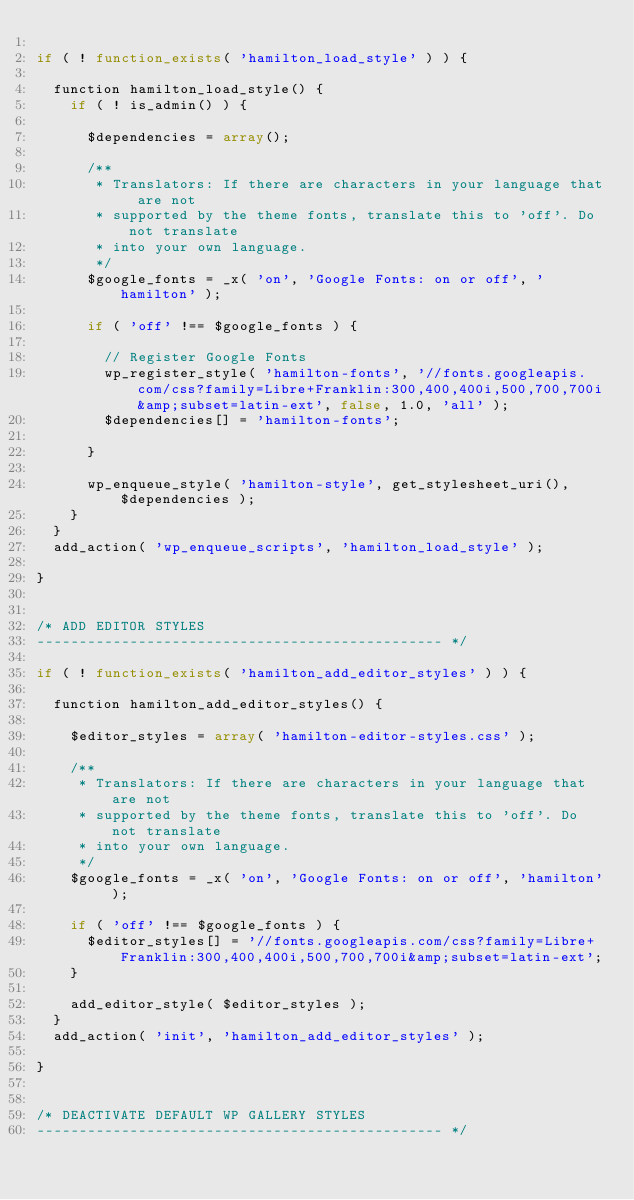Convert code to text. <code><loc_0><loc_0><loc_500><loc_500><_PHP_>
if ( ! function_exists( 'hamilton_load_style' ) ) {

	function hamilton_load_style() {
		if ( ! is_admin() ) {

			$dependencies = array();

			/**
			 * Translators: If there are characters in your language that are not
			 * supported by the theme fonts, translate this to 'off'. Do not translate
			 * into your own language.
			 */
			$google_fonts = _x( 'on', 'Google Fonts: on or off', 'hamilton' );

			if ( 'off' !== $google_fonts ) {

				// Register Google Fonts
				wp_register_style( 'hamilton-fonts', '//fonts.googleapis.com/css?family=Libre+Franklin:300,400,400i,500,700,700i&amp;subset=latin-ext', false, 1.0, 'all' );
				$dependencies[] = 'hamilton-fonts';

			}

			wp_enqueue_style( 'hamilton-style', get_stylesheet_uri(), $dependencies );
		} 
	}
	add_action( 'wp_enqueue_scripts', 'hamilton_load_style' );

}


/* ADD EDITOR STYLES
------------------------------------------------ */

if ( ! function_exists( 'hamilton_add_editor_styles' ) ) {

	function hamilton_add_editor_styles() {

		$editor_styles = array( 'hamilton-editor-styles.css' );

		/**
		 * Translators: If there are characters in your language that are not
		 * supported by the theme fonts, translate this to 'off'. Do not translate
		 * into your own language.
		 */
		$google_fonts = _x( 'on', 'Google Fonts: on or off', 'hamilton' );

		if ( 'off' !== $google_fonts ) {
			$editor_styles[] = '//fonts.googleapis.com/css?family=Libre+Franklin:300,400,400i,500,700,700i&amp;subset=latin-ext';
		}

		add_editor_style( $editor_styles );
	}
	add_action( 'init', 'hamilton_add_editor_styles' );

}


/* DEACTIVATE DEFAULT WP GALLERY STYLES
------------------------------------------------ */
</code> 